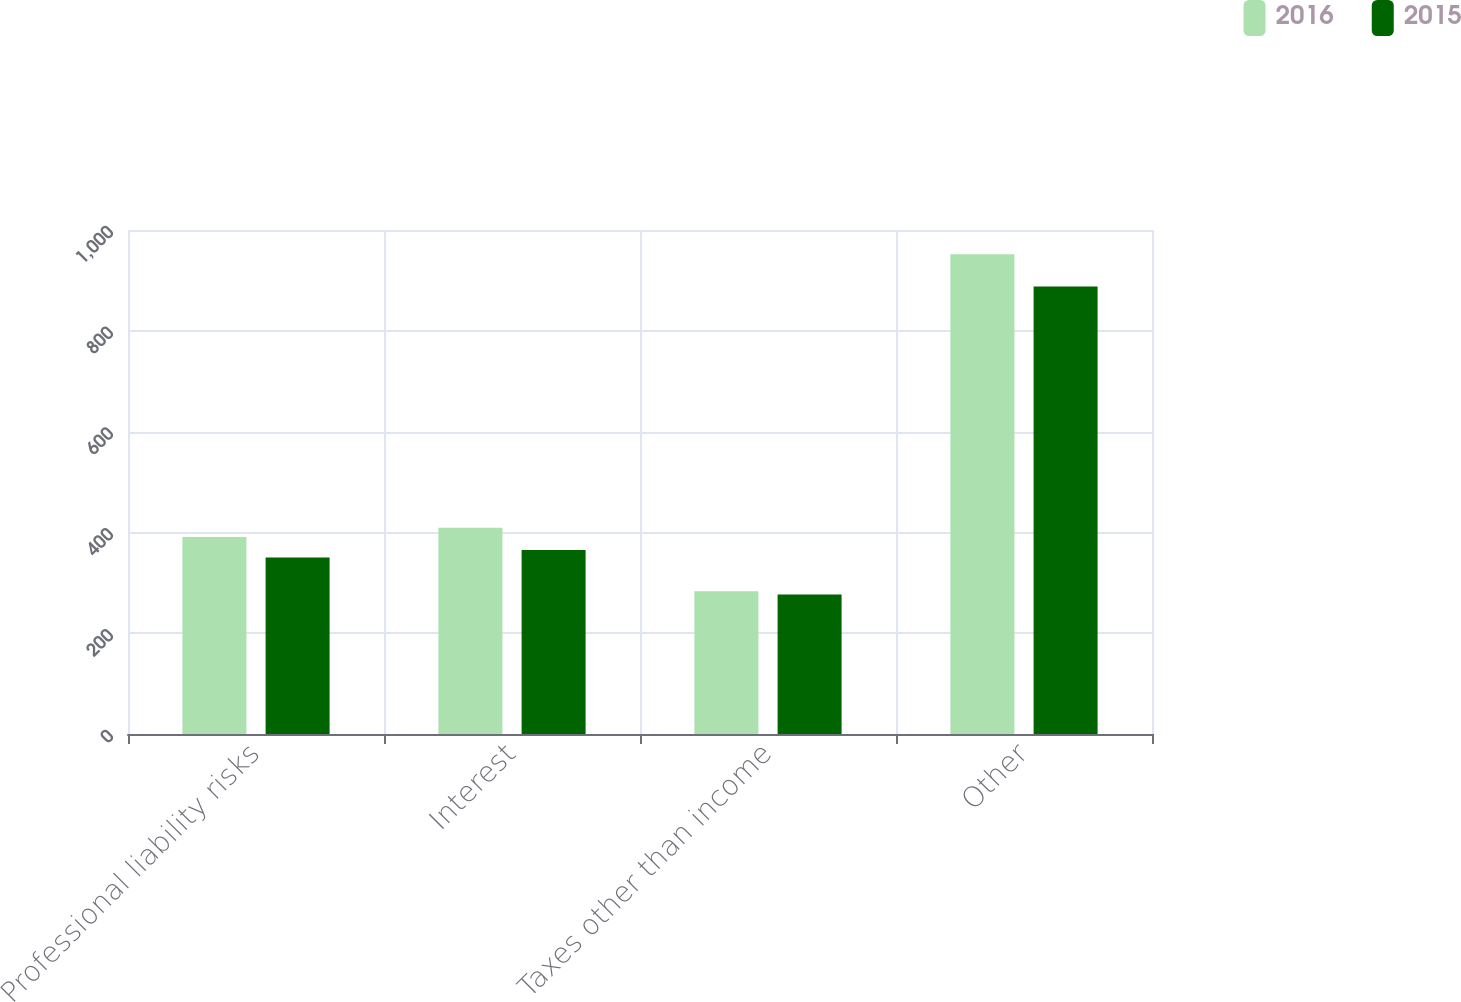Convert chart to OTSL. <chart><loc_0><loc_0><loc_500><loc_500><stacked_bar_chart><ecel><fcel>Professional liability risks<fcel>Interest<fcel>Taxes other than income<fcel>Other<nl><fcel>2016<fcel>391<fcel>409<fcel>283<fcel>952<nl><fcel>2015<fcel>350<fcel>365<fcel>277<fcel>888<nl></chart> 